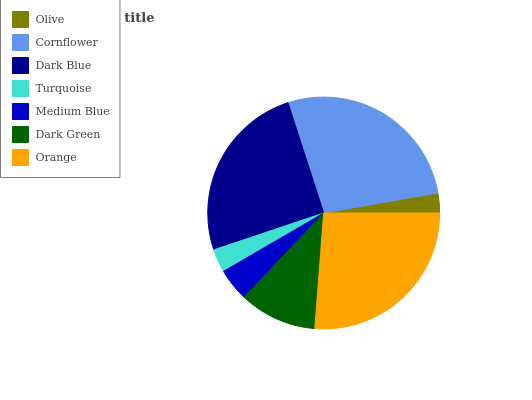Is Olive the minimum?
Answer yes or no. Yes. Is Cornflower the maximum?
Answer yes or no. Yes. Is Dark Blue the minimum?
Answer yes or no. No. Is Dark Blue the maximum?
Answer yes or no. No. Is Cornflower greater than Dark Blue?
Answer yes or no. Yes. Is Dark Blue less than Cornflower?
Answer yes or no. Yes. Is Dark Blue greater than Cornflower?
Answer yes or no. No. Is Cornflower less than Dark Blue?
Answer yes or no. No. Is Dark Green the high median?
Answer yes or no. Yes. Is Dark Green the low median?
Answer yes or no. Yes. Is Dark Blue the high median?
Answer yes or no. No. Is Medium Blue the low median?
Answer yes or no. No. 